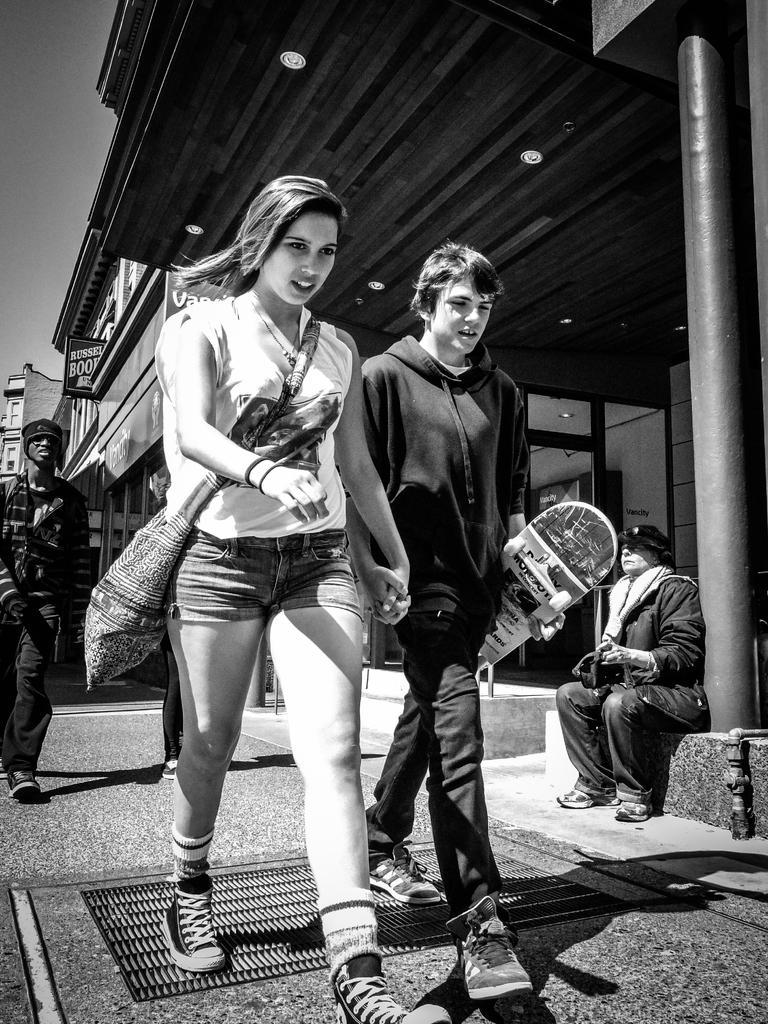Please provide a concise description of this image. This is a black and white picture, there is a woman and a man holding skateboard walking on the side of the road and another person walking behind them, on the right side there is a building and a person sitting in front of it. 